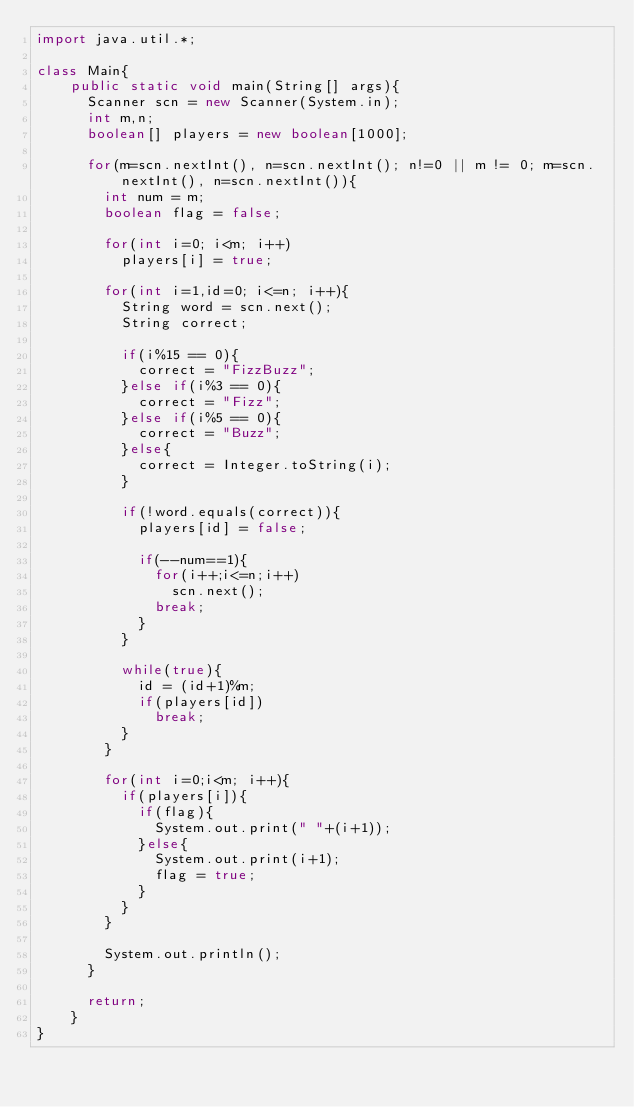Convert code to text. <code><loc_0><loc_0><loc_500><loc_500><_Java_>import java.util.*;

class Main{
    public static void main(String[] args){
    	Scanner scn = new Scanner(System.in);
    	int m,n;
    	boolean[] players = new boolean[1000];
    	
    	for(m=scn.nextInt(), n=scn.nextInt(); n!=0 || m != 0; m=scn.nextInt(), n=scn.nextInt()){
    		int num = m;
    		boolean flag = false;
    		
    		for(int i=0; i<m; i++)
    			players[i] = true;
    		
    		for(int i=1,id=0; i<=n; i++){
    			String word = scn.next();
    			String correct;
    			
    			if(i%15 == 0){
    				correct = "FizzBuzz";
    			}else if(i%3 == 0){
    				correct = "Fizz";
    			}else if(i%5 == 0){
    				correct = "Buzz";
    			}else{
    				correct = Integer.toString(i);
    			}
    			
    			if(!word.equals(correct)){
    				players[id] = false;
    				
    				if(--num==1){
    					for(i++;i<=n;i++)
    						scn.next();
    					break;	
    				}
    			}
    			
    			while(true){
    				id = (id+1)%m;
    				if(players[id])
    					break;
    			}
    		}
    		
    		for(int i=0;i<m; i++){
    			if(players[i]){
    				if(flag){
    					System.out.print(" "+(i+1));
    				}else{
    					System.out.print(i+1);
    					flag = true;
    				}
    			}
    		}
    			
    		System.out.println();
    	}
    	
    	return;
    }
}</code> 